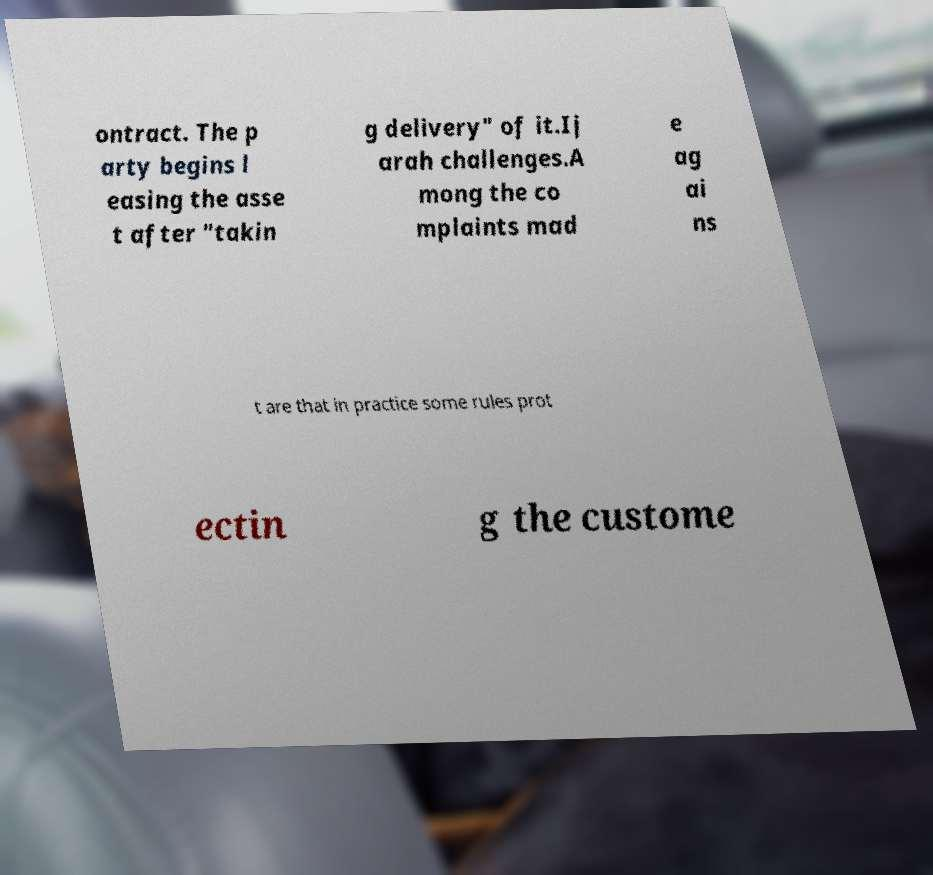Please read and relay the text visible in this image. What does it say? ontract. The p arty begins l easing the asse t after "takin g delivery" of it.Ij arah challenges.A mong the co mplaints mad e ag ai ns t are that in practice some rules prot ectin g the custome 